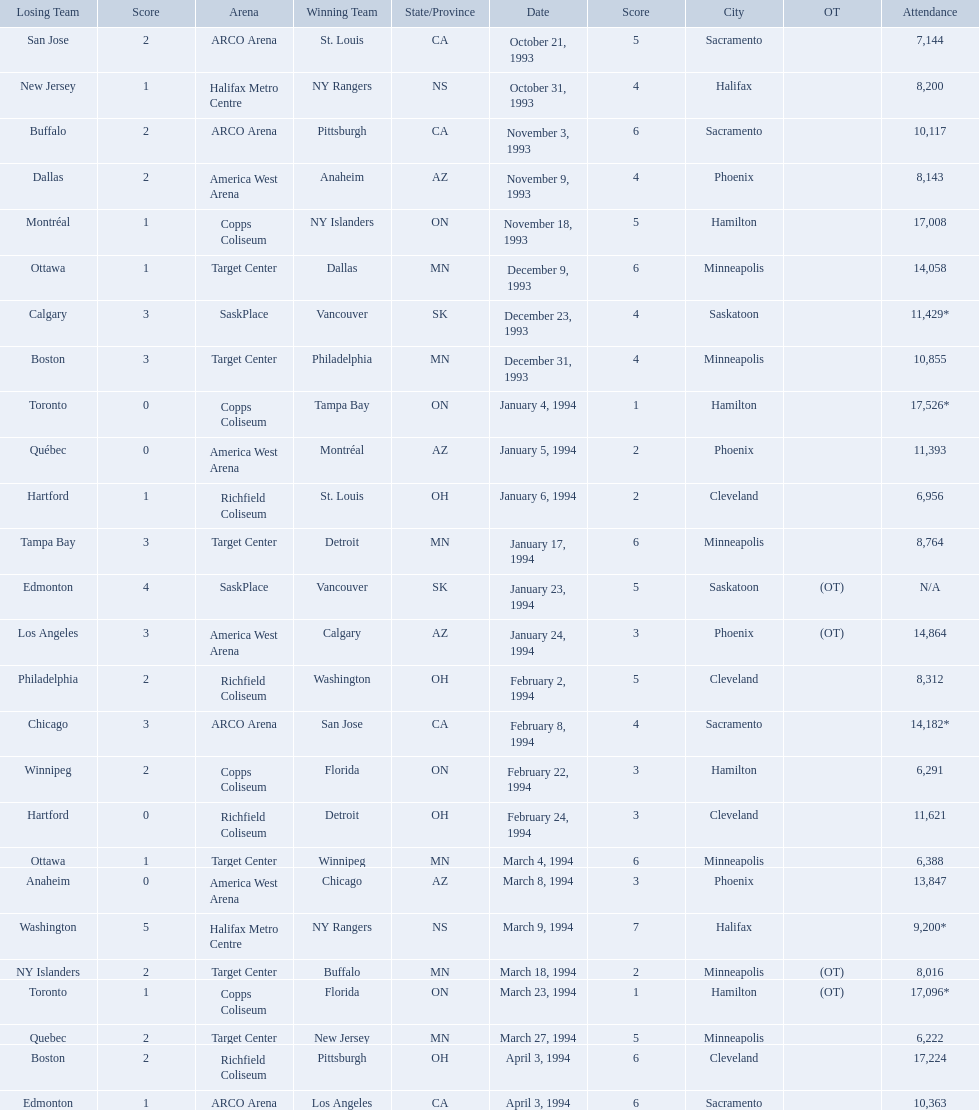What are the attendances of the 1993-94 nhl season? 7,144, 8,200, 10,117, 8,143, 17,008, 14,058, 11,429*, 10,855, 17,526*, 11,393, 6,956, 8,764, N/A, 14,864, 8,312, 14,182*, 6,291, 11,621, 6,388, 13,847, 9,200*, 8,016, 17,096*, 6,222, 17,224, 10,363. Which of these is the highest attendance? 17,526*. Which date did this attendance occur? January 4, 1994. 